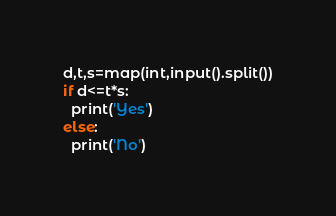Convert code to text. <code><loc_0><loc_0><loc_500><loc_500><_Python_>d,t,s=map(int,input().split())
if d<=t*s:
  print('Yes')
else:
  print('No')</code> 